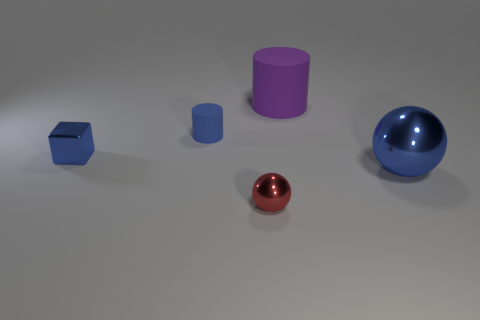What materials do the objects in the image appear to be made from? The objects in the image seem to have a smooth, reflective surface, suggesting they could be made from materials such as polished metal or plastic with a high-gloss finish. 